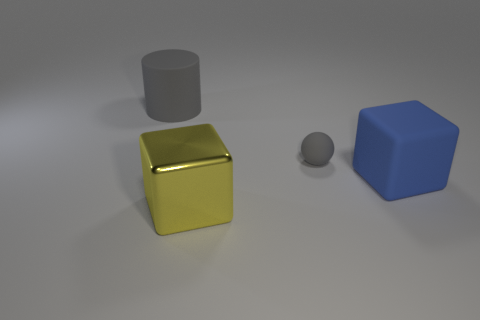Are there any other things that have the same size as the gray sphere?
Your response must be concise. No. Is there anything else that has the same material as the yellow block?
Your response must be concise. No. Is there anything else of the same color as the matte ball?
Make the answer very short. Yes. There is a rubber thing to the left of the small ball; is its size the same as the cube to the right of the yellow object?
Provide a succinct answer. Yes. Are there an equal number of tiny gray objects that are right of the blue cube and yellow things that are behind the large yellow block?
Provide a succinct answer. Yes. Is the size of the yellow cube the same as the cube that is behind the metallic block?
Your answer should be compact. Yes. Is there a object that is to the right of the gray matte thing left of the large metal object?
Make the answer very short. Yes. Are there any large red metal objects of the same shape as the large blue object?
Your response must be concise. No. What number of small gray balls are behind the gray rubber object in front of the large matte thing to the left of the large metal cube?
Provide a succinct answer. 0. There is a cylinder; is it the same color as the large matte thing that is to the right of the big yellow shiny object?
Ensure brevity in your answer.  No. 